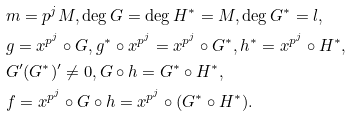Convert formula to latex. <formula><loc_0><loc_0><loc_500><loc_500>& m = p ^ { j } M , \deg G = \deg H ^ { * } = M , \deg G ^ { * } = l , \\ & g = x ^ { p ^ { j } } \circ G , g ^ { * } \circ x ^ { p ^ { j } } = x ^ { p ^ { j } } \circ G ^ { * } , h ^ { * } = x ^ { p ^ { j } } \circ H ^ { * } , \\ & G ^ { \prime } ( G ^ { * } ) ^ { \prime } \neq 0 , G \circ h = G ^ { * } \circ H ^ { * } , \\ & f = x ^ { p ^ { j } } \circ G \circ h = x ^ { p ^ { j } } \circ ( G ^ { * } \circ H ^ { * } ) .</formula> 